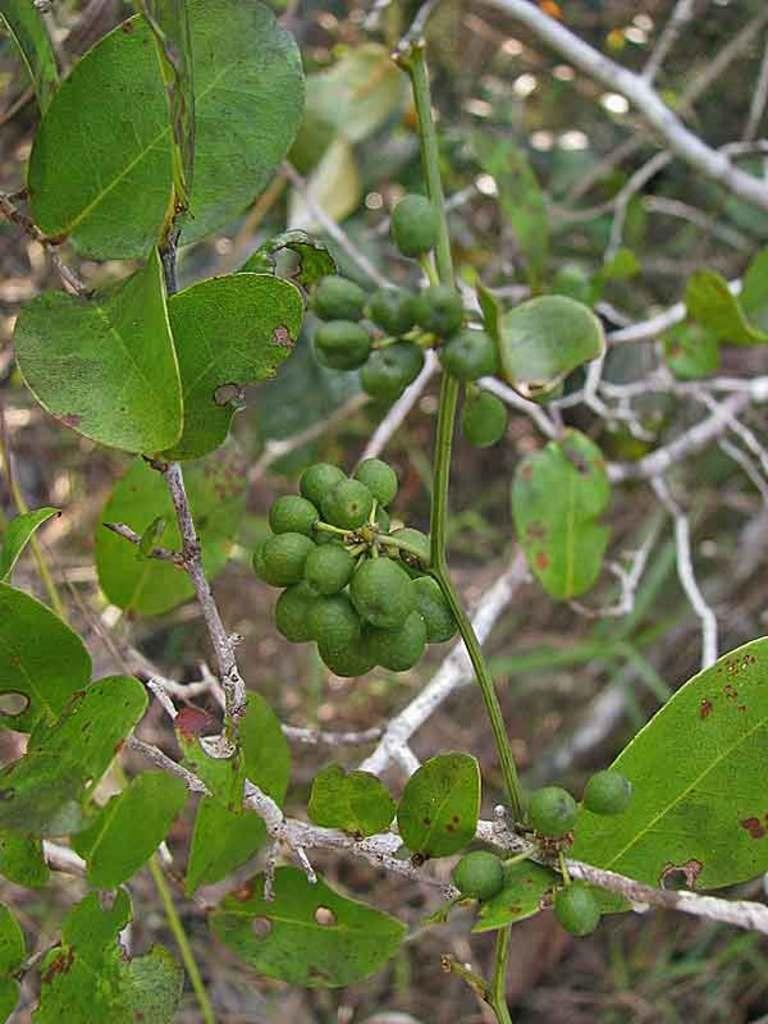What type of vegetation can be seen in the image? There are leaves and tree branches visible in the image. What else is present in the image besides vegetation? Raw fruits are present in the image. What type of tax is being discussed in the image? There is no discussion of tax in the image; it features leaves, tree branches, and raw fruits. 